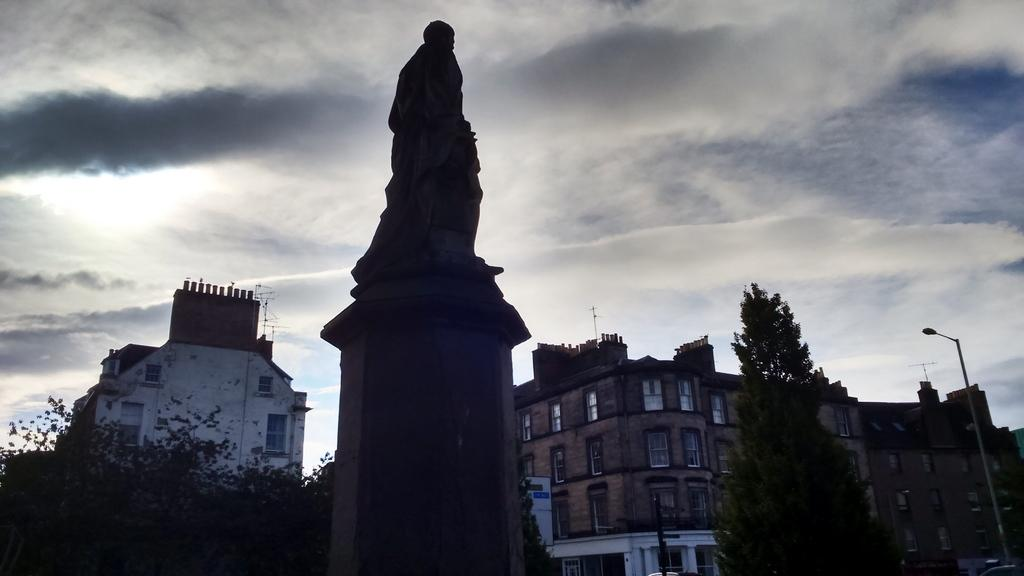What is the main subject of the image? There is a sculpture in the image. What else can be seen in the image besides the sculpture? There are buildings, windows, trees, a light pole, and the sky visible in the image. Can you describe the buildings in the image? The windows of the buildings are visible in the image. What is the condition of the sky in the image? The sky is cloudy in the image. What type of industry is depicted in the sculpture? The image does not depict any industry; it features a sculpture and other elements such as buildings, trees, and a light pole. How does the sculpture shake in the image? The sculpture does not shake in the image; it is stationary. 